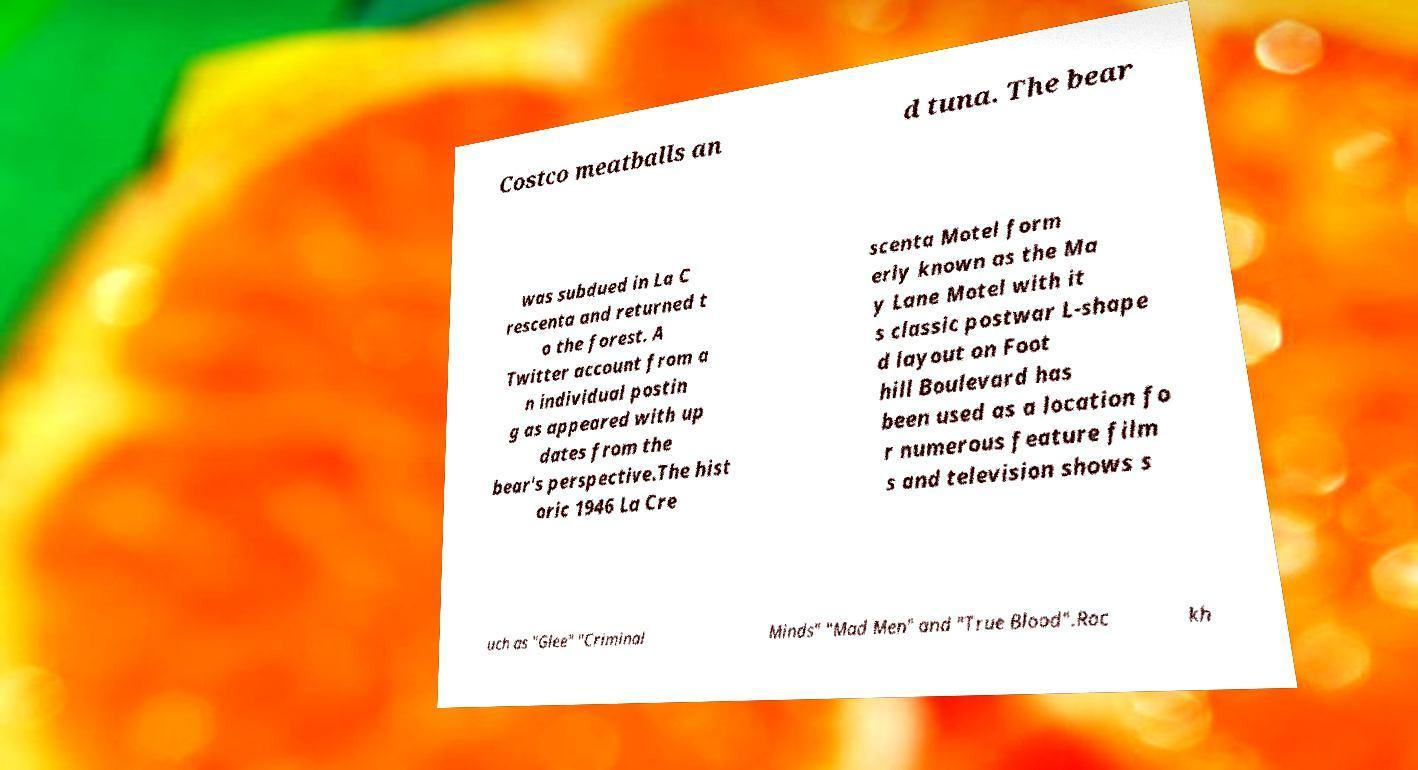I need the written content from this picture converted into text. Can you do that? Costco meatballs an d tuna. The bear was subdued in La C rescenta and returned t o the forest. A Twitter account from a n individual postin g as appeared with up dates from the bear's perspective.The hist oric 1946 La Cre scenta Motel form erly known as the Ma y Lane Motel with it s classic postwar L-shape d layout on Foot hill Boulevard has been used as a location fo r numerous feature film s and television shows s uch as "Glee" "Criminal Minds" "Mad Men" and "True Blood".Roc kh 